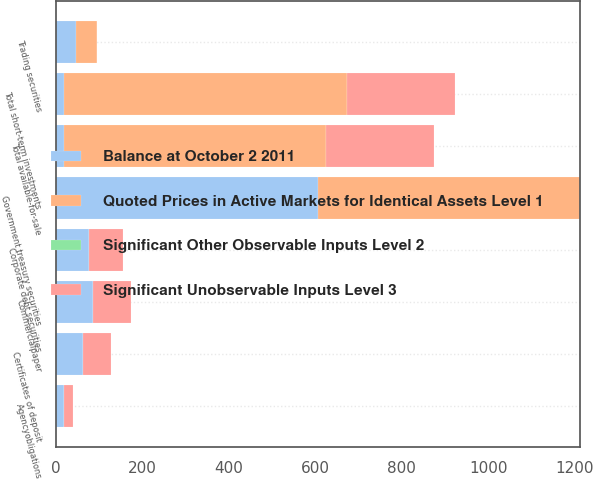Convert chart. <chart><loc_0><loc_0><loc_500><loc_500><stacked_bar_chart><ecel><fcel>Agencyobligations<fcel>Commercialpaper<fcel>Corporate debt securities<fcel>Government treasury securities<fcel>Certificates of deposit<fcel>Total available-for-sale<fcel>Trading securities<fcel>Total short-term investments<nl><fcel>Balance at October 2 2011<fcel>20<fcel>87<fcel>78<fcel>606<fcel>64<fcel>20<fcel>47.6<fcel>20<nl><fcel>Quoted Prices in Active Markets for Identical Assets Level 1<fcel>0<fcel>0<fcel>0<fcel>606<fcel>0<fcel>606<fcel>47.6<fcel>653.6<nl><fcel>Significant Unobservable Inputs Level 3<fcel>20<fcel>87<fcel>78<fcel>0<fcel>64<fcel>249<fcel>0<fcel>249<nl><fcel>Significant Other Observable Inputs Level 2<fcel>0<fcel>0<fcel>0<fcel>0<fcel>0<fcel>0<fcel>0<fcel>0<nl></chart> 